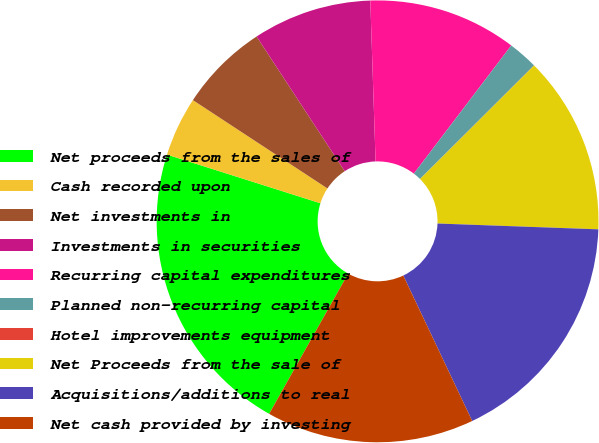<chart> <loc_0><loc_0><loc_500><loc_500><pie_chart><fcel>Net proceeds from the sales of<fcel>Cash recorded upon<fcel>Net investments in<fcel>Investments in securities<fcel>Recurring capital expenditures<fcel>Planned non-recurring capital<fcel>Hotel improvements equipment<fcel>Net Proceeds from the sale of<fcel>Acquisitions/additions to real<fcel>Net cash provided by investing<nl><fcel>21.72%<fcel>4.36%<fcel>6.53%<fcel>8.7%<fcel>10.87%<fcel>2.18%<fcel>0.01%<fcel>13.04%<fcel>17.38%<fcel>15.21%<nl></chart> 